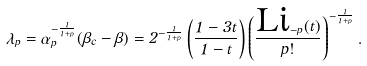<formula> <loc_0><loc_0><loc_500><loc_500>\lambda _ { p } = \alpha _ { p } ^ { - \frac { 1 } { 1 + p } } ( \beta _ { c } - \beta ) = 2 ^ { - \frac { 1 } { 1 + p } } \left ( \frac { 1 - 3 t } { 1 - t } \right ) \left ( \frac { \text {Li} _ { - p } ( t ) } { p ! } \right ) ^ { - \frac { 1 } { 1 + p } } .</formula> 